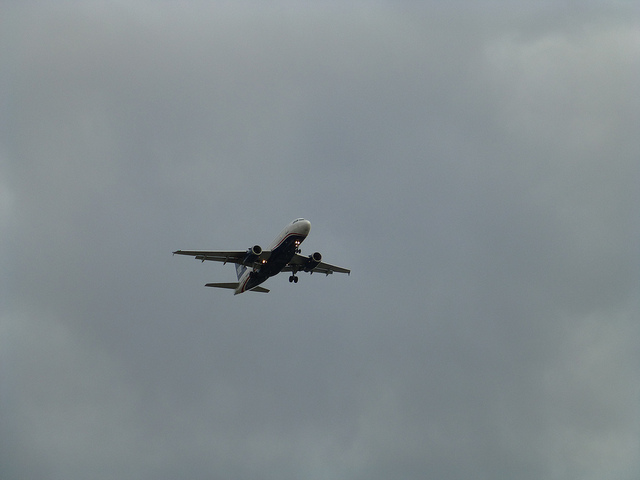<image>Do you think this was for an airshow? I don't know whether this was for an airshow. Do you think this was for an airshow? I am not sure if this was for an airshow. It is unanswerable. 